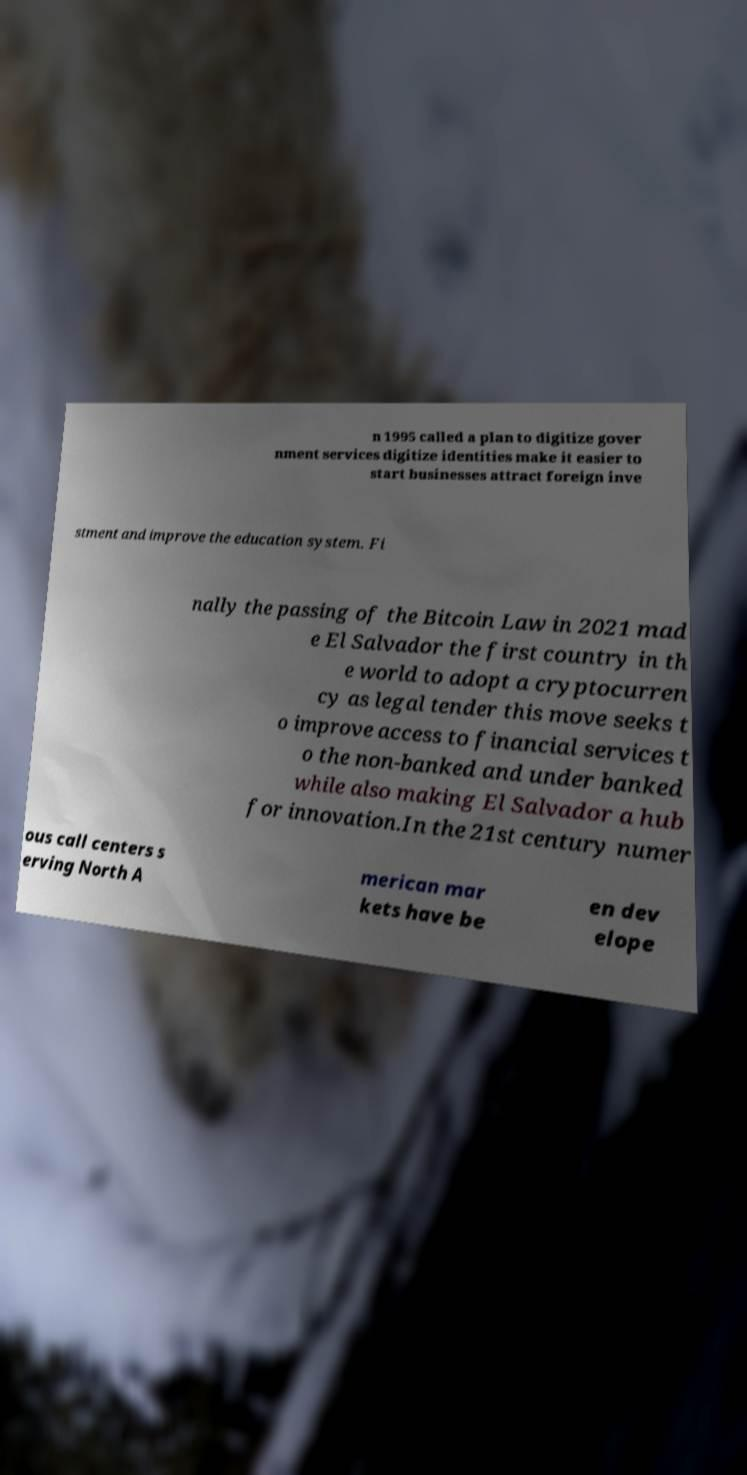Can you read and provide the text displayed in the image?This photo seems to have some interesting text. Can you extract and type it out for me? n 1995 called a plan to digitize gover nment services digitize identities make it easier to start businesses attract foreign inve stment and improve the education system. Fi nally the passing of the Bitcoin Law in 2021 mad e El Salvador the first country in th e world to adopt a cryptocurren cy as legal tender this move seeks t o improve access to financial services t o the non-banked and under banked while also making El Salvador a hub for innovation.In the 21st century numer ous call centers s erving North A merican mar kets have be en dev elope 